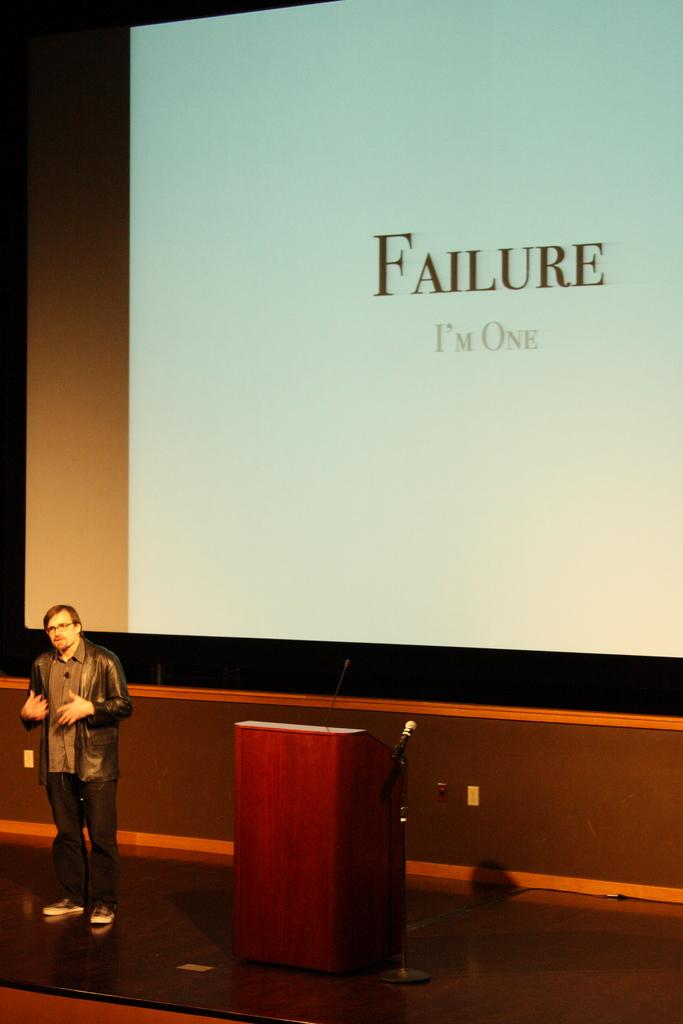What is located on the left side of the image? There is a man on the left side of the image. What is the man wearing in the image? The man is wearing a jacket, shirt, trouser, and shoes. What can be seen in the middle of the image? There is a podium in the middle of the image. What is on the podium? A microphone is present on the podium. What is visible at the top of the image? There is a screen at the top of the image. What is displayed on the screen? Text is visible on the screen. What type of meat is being served on the podium in the image? There is no meat present in the image; the podium has a microphone on it. How many dinosaurs are visible on the screen in the image? There are no dinosaurs visible on the screen in the image; the screen displays text. 